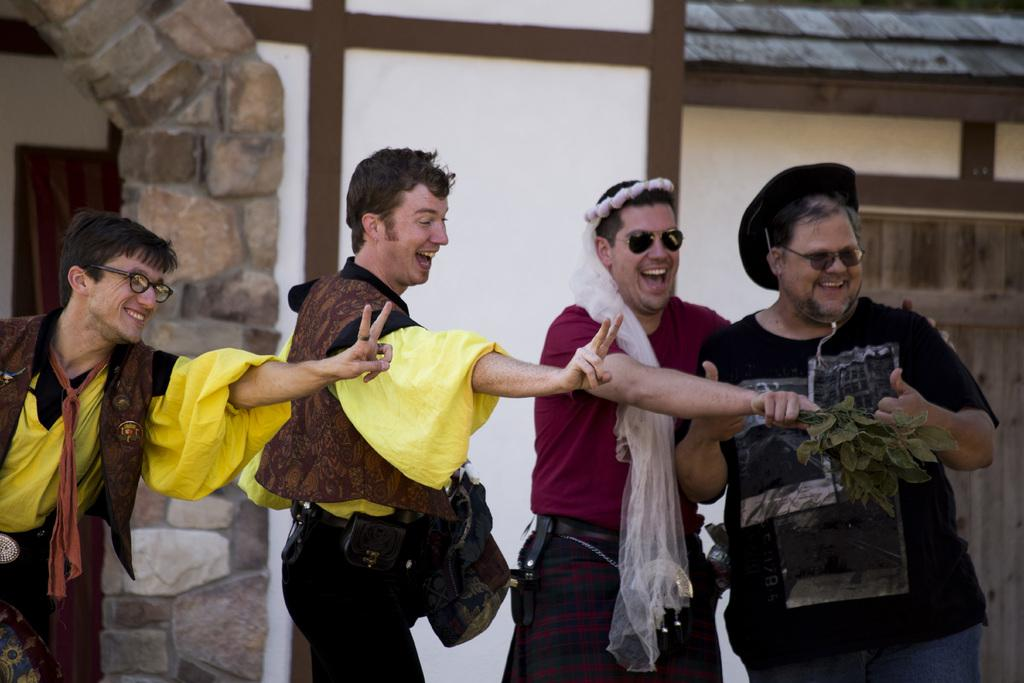How many people are in the image? There is a group of people standing in the image. What is one person holding in his hand? One person is holding leaves in his hand. What can be seen in the background of the image? There is a building in the background of the image. What features does the building have? The building has windows, an arch, and a roof. Can you see any fish swimming in the lake in the image? There is no lake present in the image. What color are the person's lips in the image? The provided facts do not mention the color of anyone's lips in the image. 